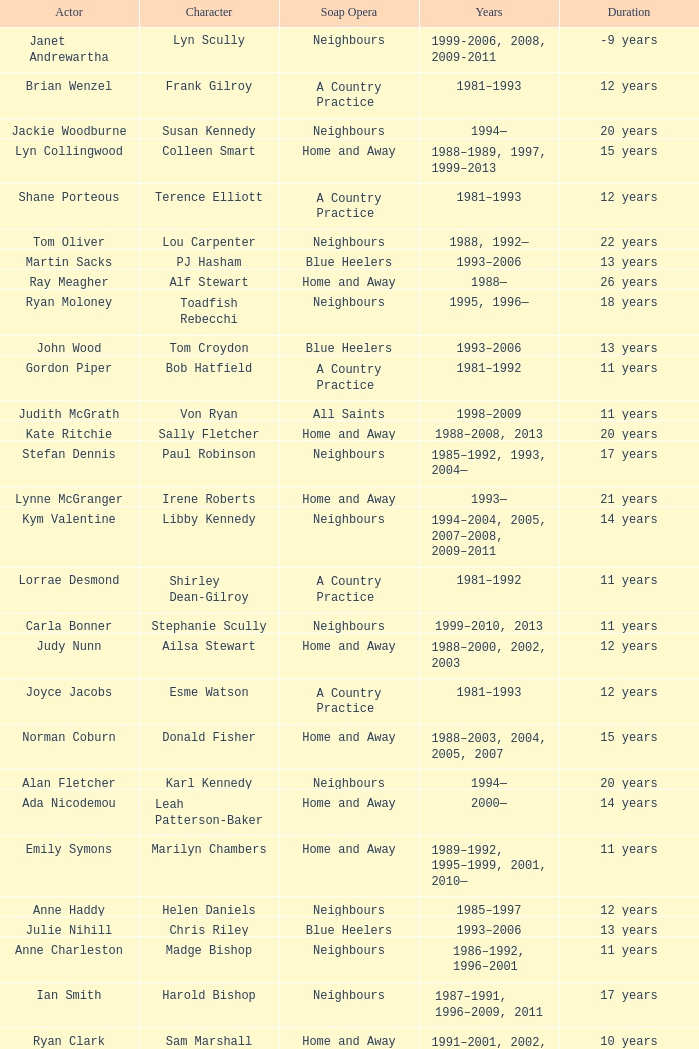Which actor played on Home and Away for 20 years? Kate Ritchie. 